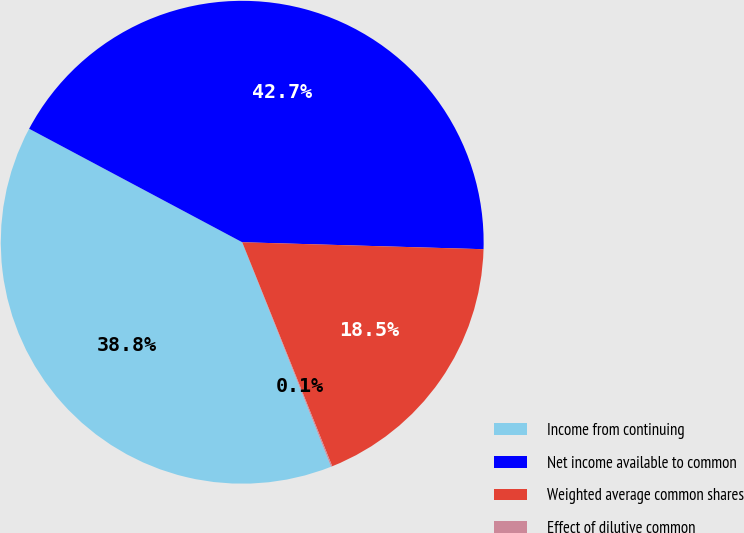Convert chart to OTSL. <chart><loc_0><loc_0><loc_500><loc_500><pie_chart><fcel>Income from continuing<fcel>Net income available to common<fcel>Weighted average common shares<fcel>Effect of dilutive common<nl><fcel>38.79%<fcel>42.67%<fcel>18.46%<fcel>0.08%<nl></chart> 